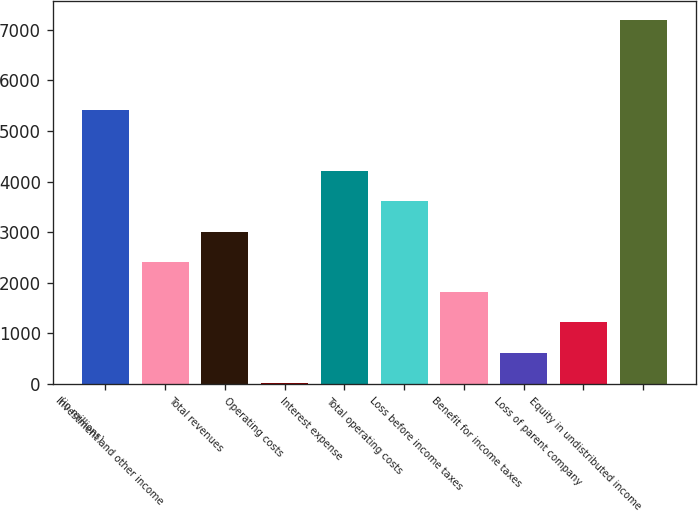<chart> <loc_0><loc_0><loc_500><loc_500><bar_chart><fcel>(in millions)<fcel>Investment and other income<fcel>Total revenues<fcel>Operating costs<fcel>Interest expense<fcel>Total operating costs<fcel>Loss before income taxes<fcel>Benefit for income taxes<fcel>Loss of parent company<fcel>Equity in undistributed income<nl><fcel>5407.1<fcel>2412.6<fcel>3011.5<fcel>17<fcel>4209.3<fcel>3610.4<fcel>1813.7<fcel>615.9<fcel>1214.8<fcel>7203.8<nl></chart> 